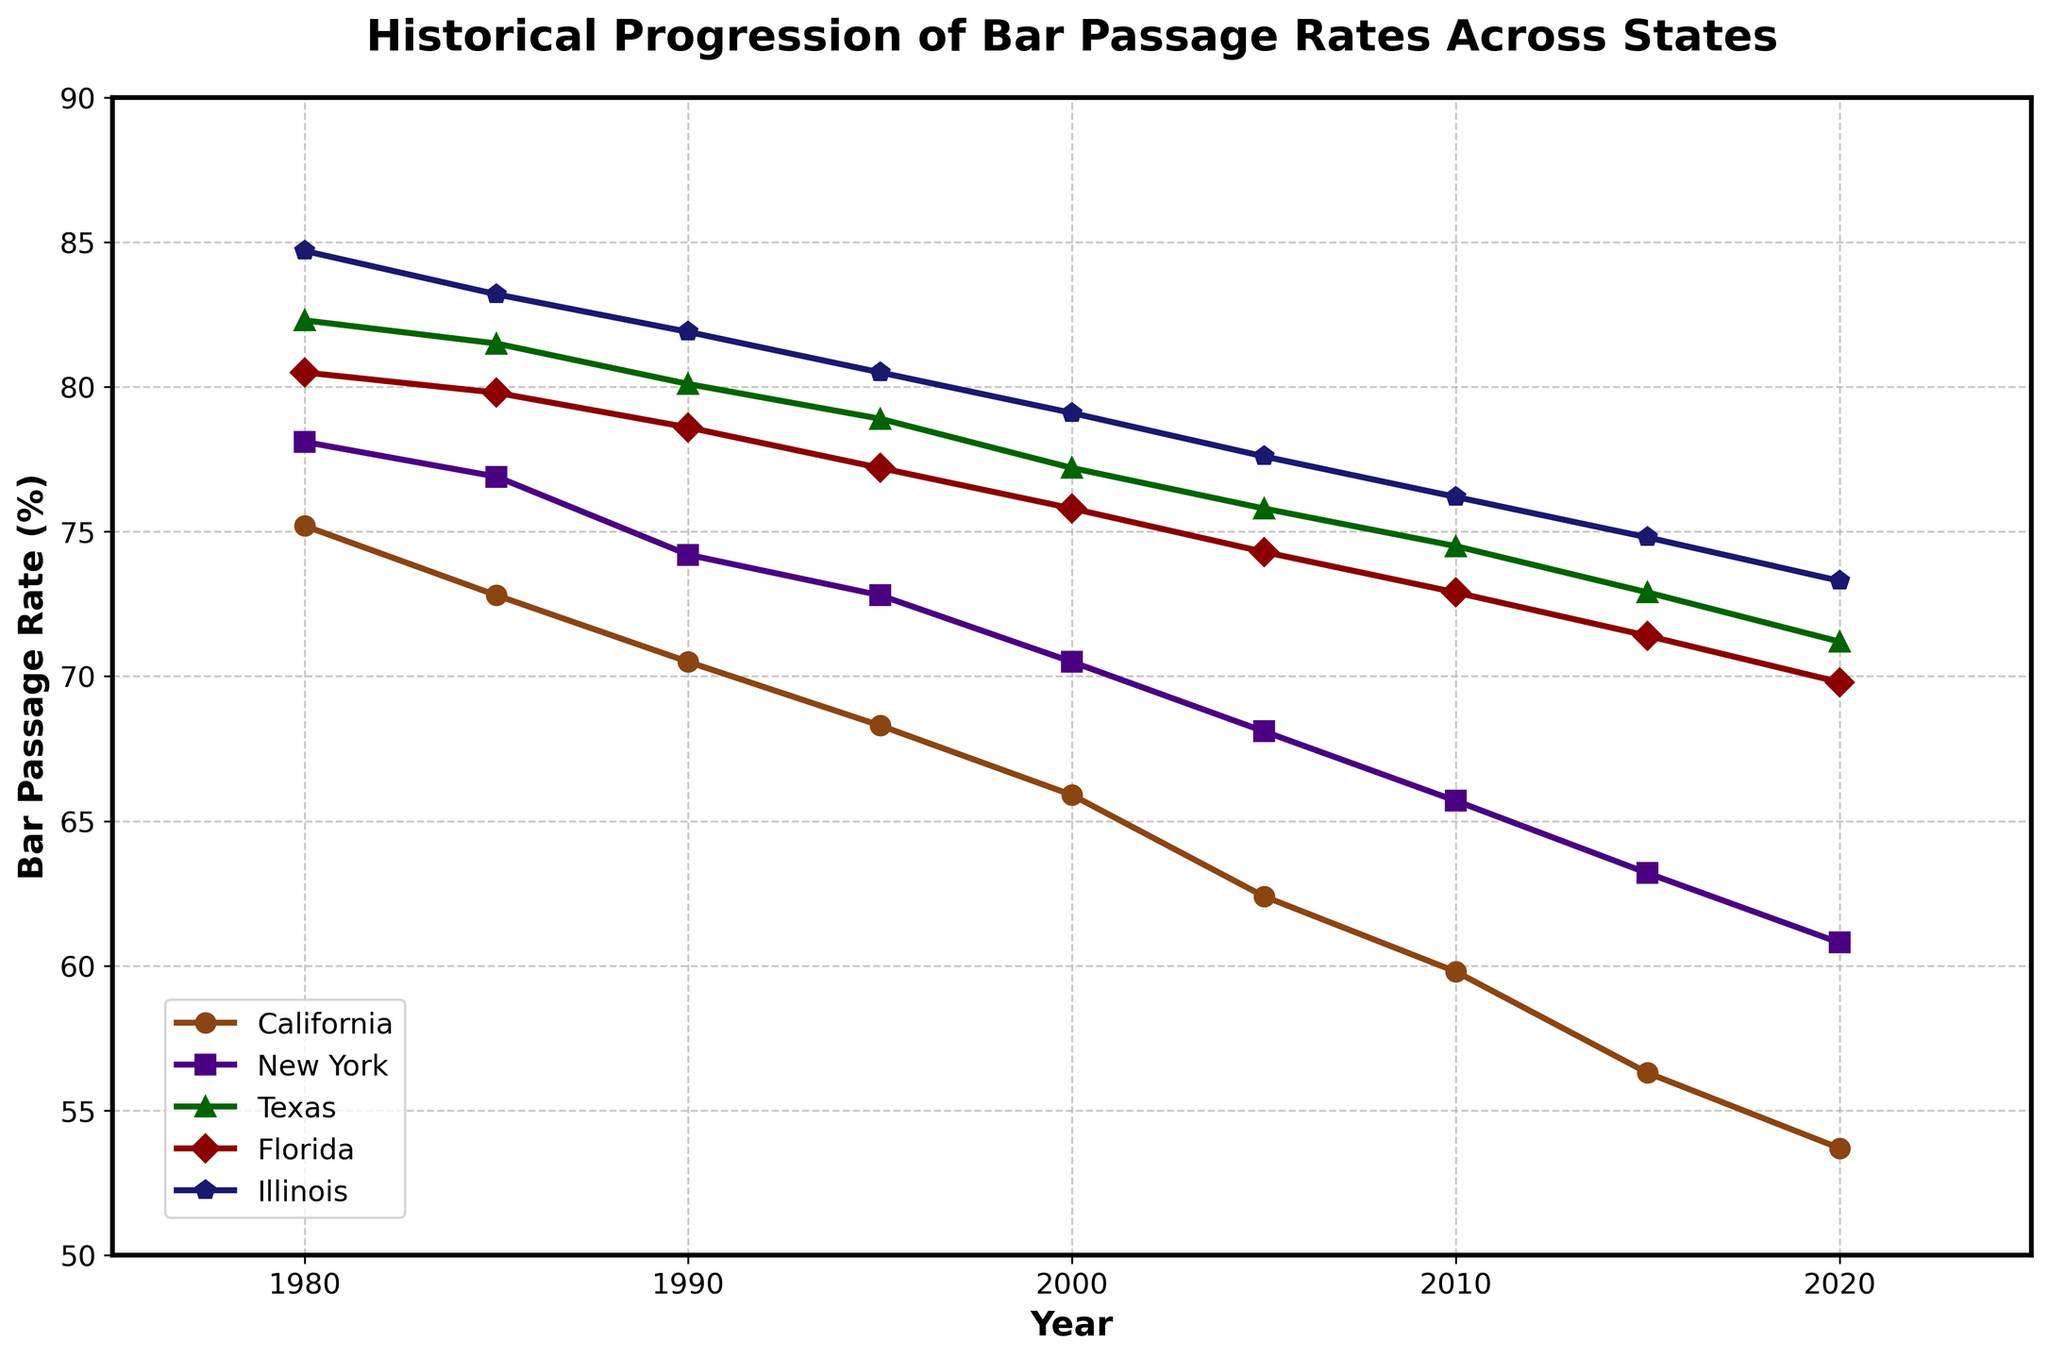What is the trend of the bar passage rate in California from 1980 to 2020? The line chart for California shows a continuous decline in the bar passage rate from 75.2% in 1980 to 53.7% in 2020.
Answer: Declining Which state had the highest bar passage rate in 1985 and what was the rate? Looking at the values for 1985, Illinois has the highest bar passage rate at 83.2%.
Answer: Illinois, 83.2% Between which consecutive years did New York experience the sharpest decline in bar passage rates? Observing the plot, the sharpest decline occurs between 1985 (76.9%) and 1990 (74.2%), with a decrease of 2.7%.
Answer: 1985 to 1990 What is the difference in the bar passage rate between Texas and Florida in 2010? In 2010, the bar passage rate for Texas is 74.5% and for Florida, it is 72.9%. The difference is 74.5% - 72.9% = 1.6%.
Answer: 1.6% Which state shows the most consistent decrease in bar passage rates over the years? Examining the trends, all states show a decrease, but California exhibits the most consistent, steady decline in its passage rates from 75.2% in 1980 to 53.7% in 2020.
Answer: California How does the bar passage rate in Illinois in 2000 compare to that in Texas in 2020? In 2000, the bar passage rate in Illinois is 79.1%, while in Texas in 2020, it is 71.2%. Illinois's rate in 2000 is higher by 7.9%.
Answer: Illinois (2000) is higher by 7.9% Which state had the lowest bar passage rate in 2020 and what was the rate? According to the figure, California has the lowest bar passage rate in 2020 at 53.7%.
Answer: California, 53.7% What is the average bar passage rate in Florida across all the years shown? Adding the passage rates for Florida: (80.5 + 79.8 + 78.6 + 77.2 + 75.8 + 74.3 + 72.9 + 71.4 + 69.8) / 9 = 76.7%
Answer: 76.7% From 1995 to 2000, which state experienced the least change in the bar passage rate? Calculating the difference: California (68.3 to 65.9 = 2.4), New York (72.8 to 70.5 = 2.3), Texas (78.9 to 77.2 = 1.7), Florida (77.2 to 75.8 = 1.4), Illinois (80.5 to 79.1 = 1.4). Both Florida and Illinois have the least change of 1.4%.
Answer: Florida and Illinois 